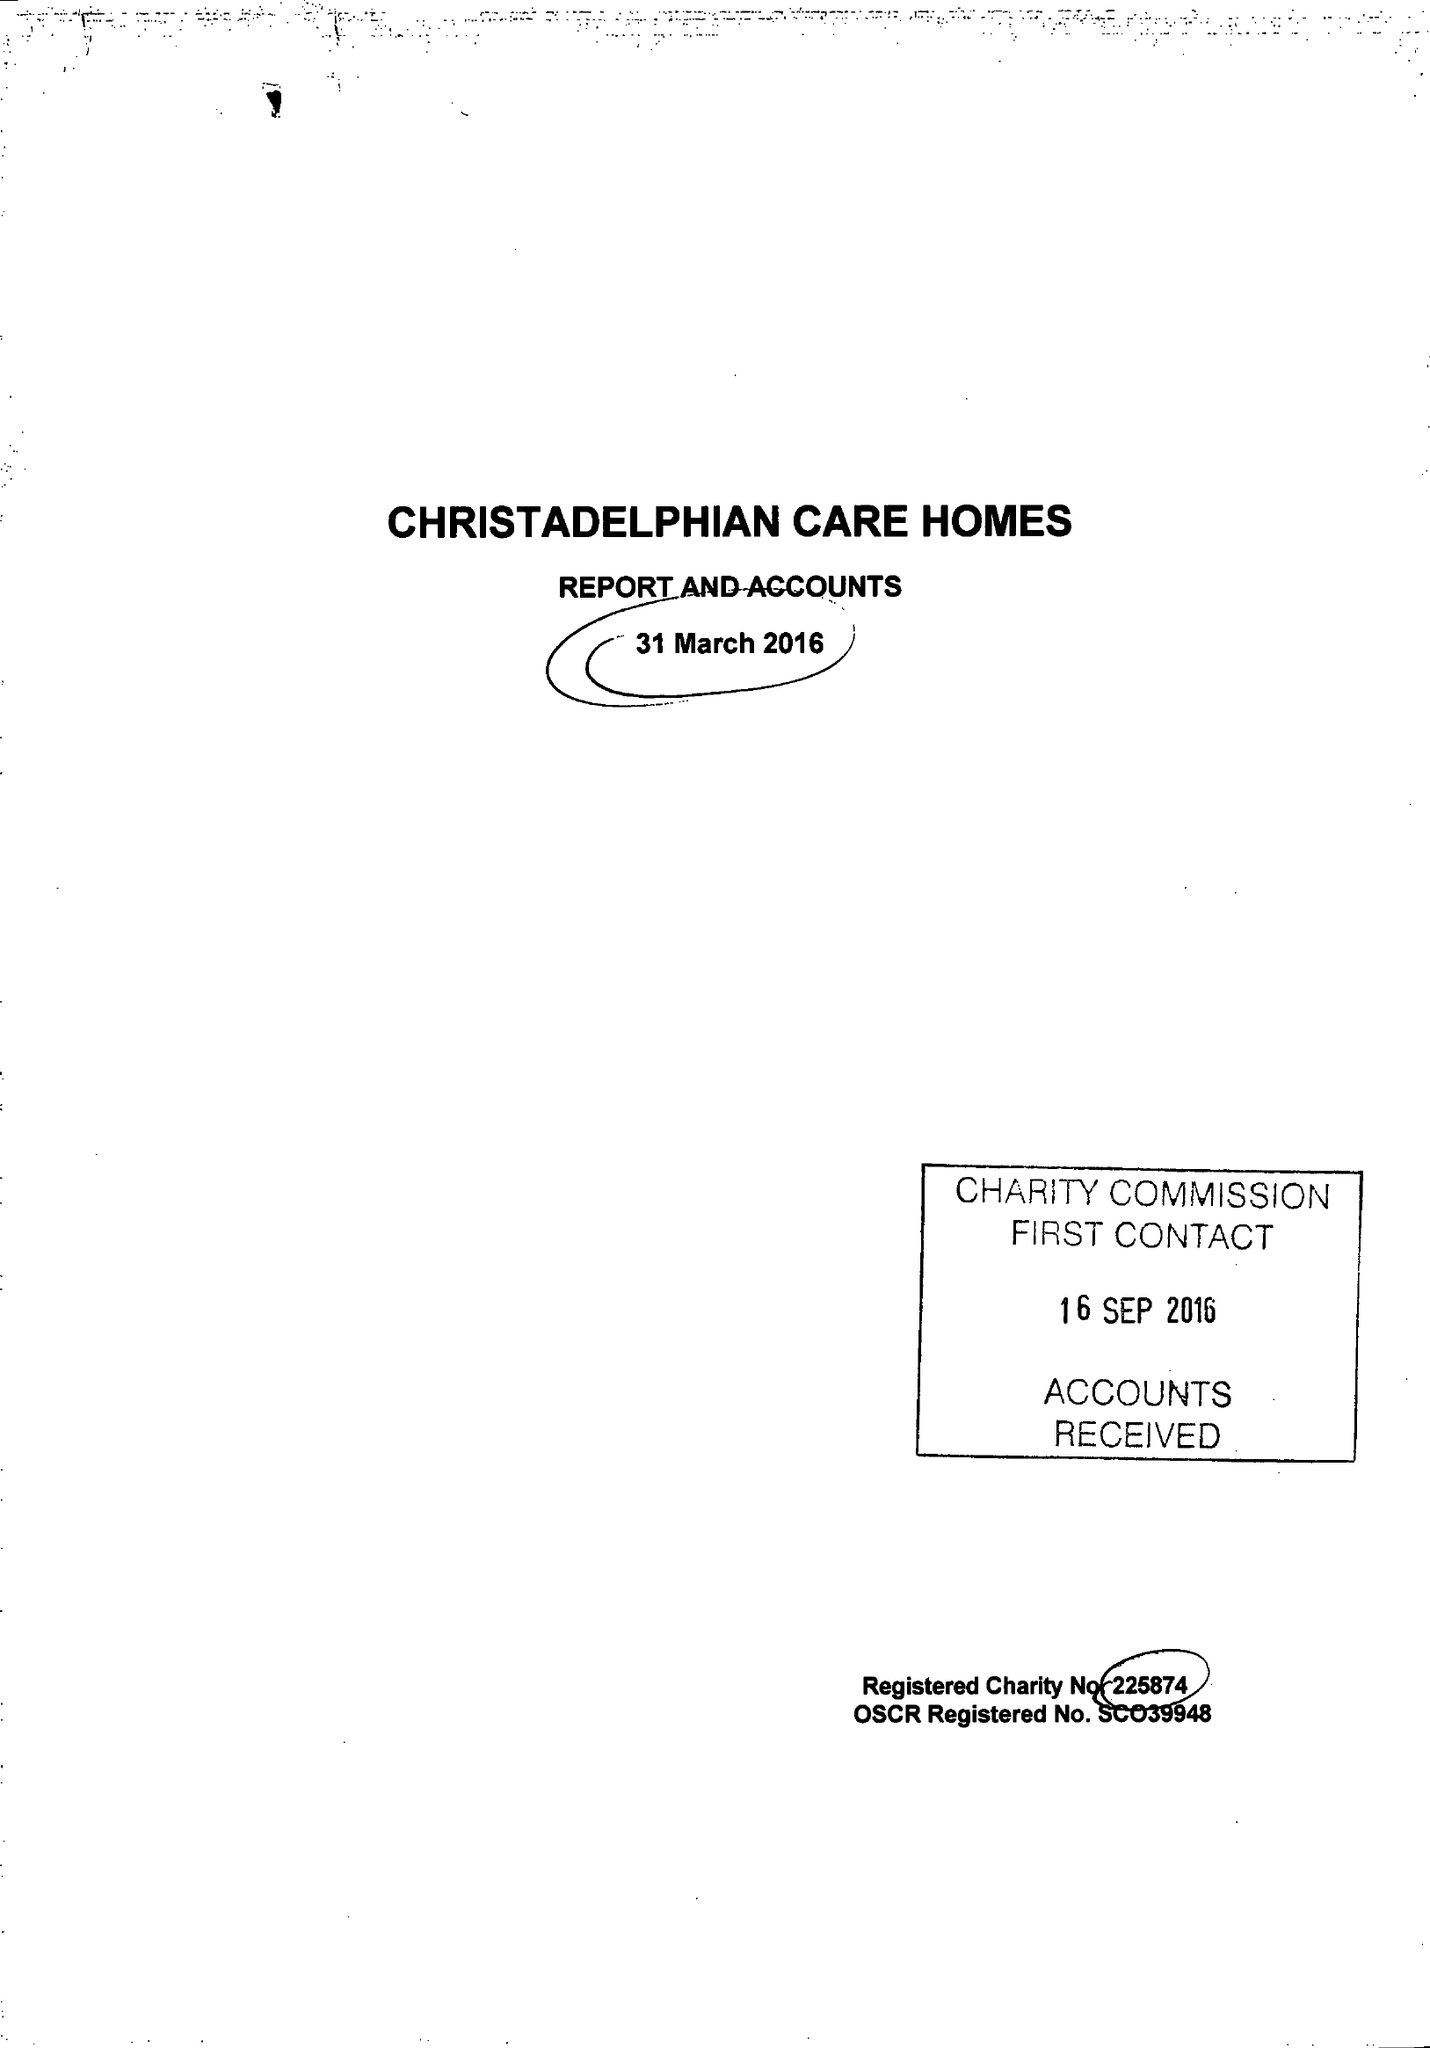What is the value for the charity_name?
Answer the question using a single word or phrase. Christadelphian Care Homes 